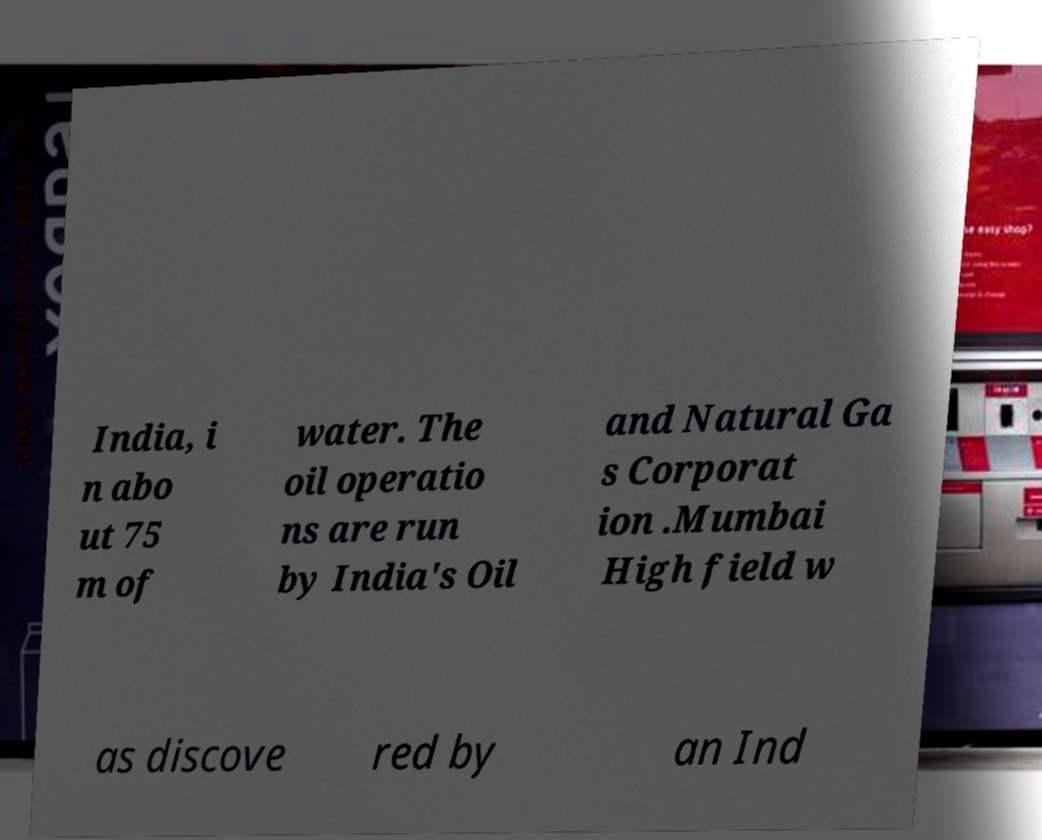For documentation purposes, I need the text within this image transcribed. Could you provide that? India, i n abo ut 75 m of water. The oil operatio ns are run by India's Oil and Natural Ga s Corporat ion .Mumbai High field w as discove red by an Ind 